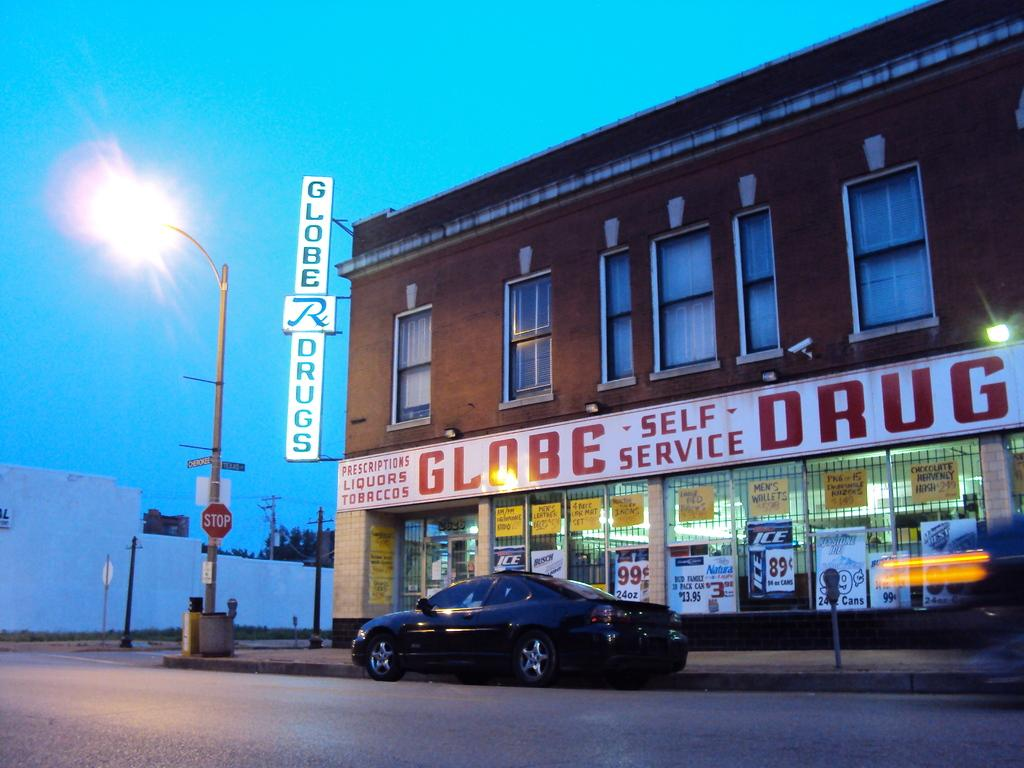What is the main subject of the image? There is a car on the road in the image. What can be seen in the background of the image? There is a building, poles, lights, and a name board in the background of the image. How many robins are perched on the car in the image? There are no robins present in the image. What type of lumber is being used to construct the building in the background? The image does not provide information about the type of lumber used in the construction of the building. 